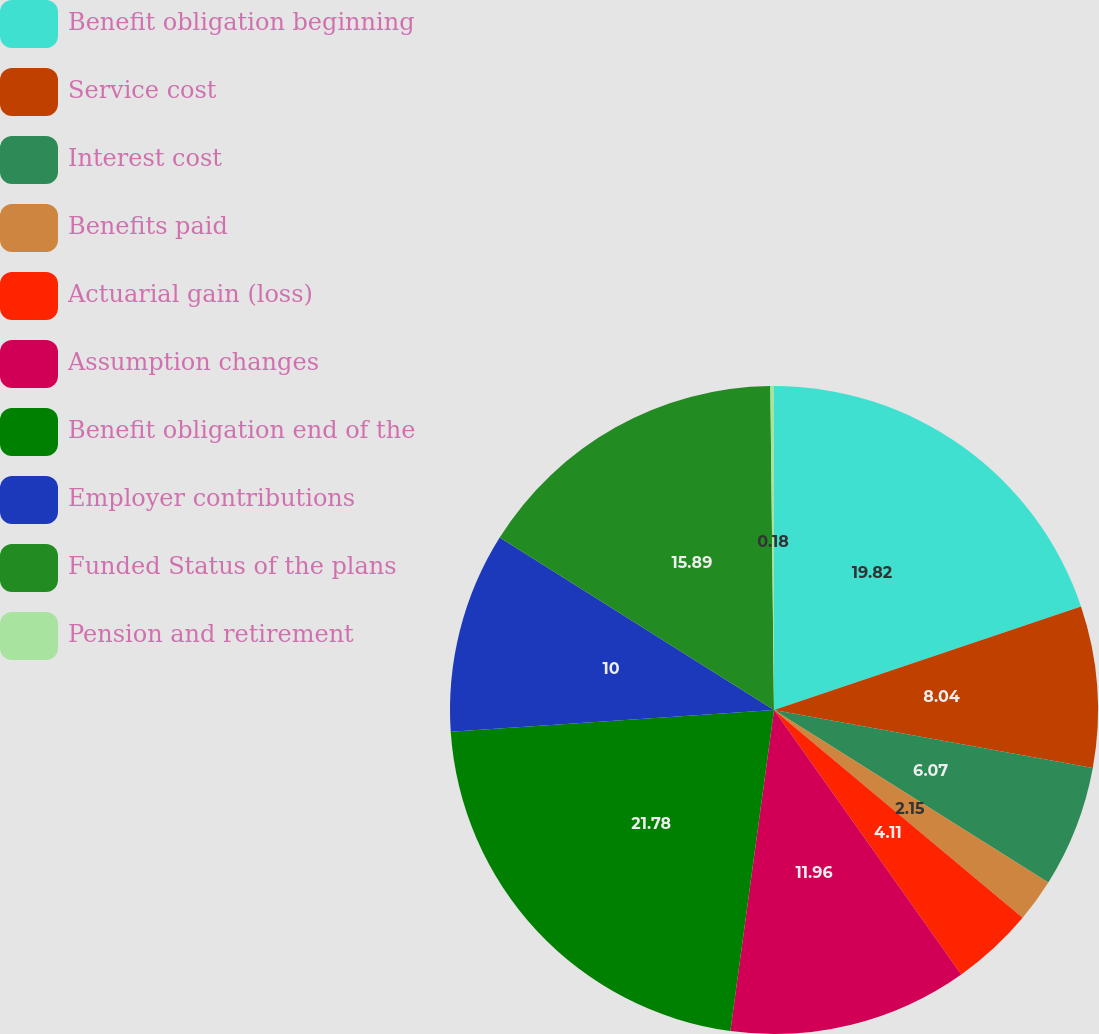Convert chart. <chart><loc_0><loc_0><loc_500><loc_500><pie_chart><fcel>Benefit obligation beginning<fcel>Service cost<fcel>Interest cost<fcel>Benefits paid<fcel>Actuarial gain (loss)<fcel>Assumption changes<fcel>Benefit obligation end of the<fcel>Employer contributions<fcel>Funded Status of the plans<fcel>Pension and retirement<nl><fcel>19.82%<fcel>8.04%<fcel>6.07%<fcel>2.15%<fcel>4.11%<fcel>11.96%<fcel>21.78%<fcel>10.0%<fcel>15.89%<fcel>0.18%<nl></chart> 